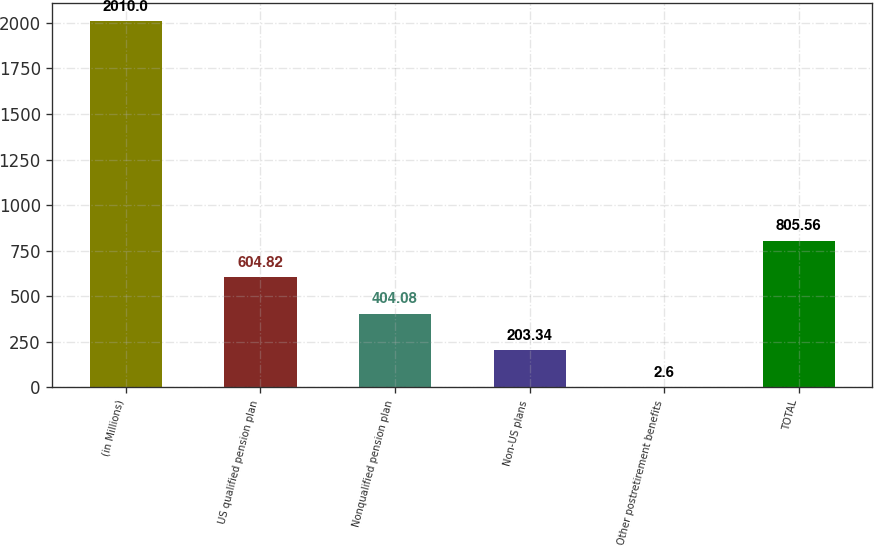<chart> <loc_0><loc_0><loc_500><loc_500><bar_chart><fcel>(in Millions)<fcel>US qualified pension plan<fcel>Nonqualified pension plan<fcel>Non-US plans<fcel>Other postretirement benefits<fcel>TOTAL<nl><fcel>2010<fcel>604.82<fcel>404.08<fcel>203.34<fcel>2.6<fcel>805.56<nl></chart> 